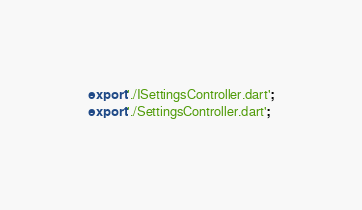Convert code to text. <code><loc_0><loc_0><loc_500><loc_500><_Dart_>export './ISettingsController.dart';
export './SettingsController.dart';
</code> 